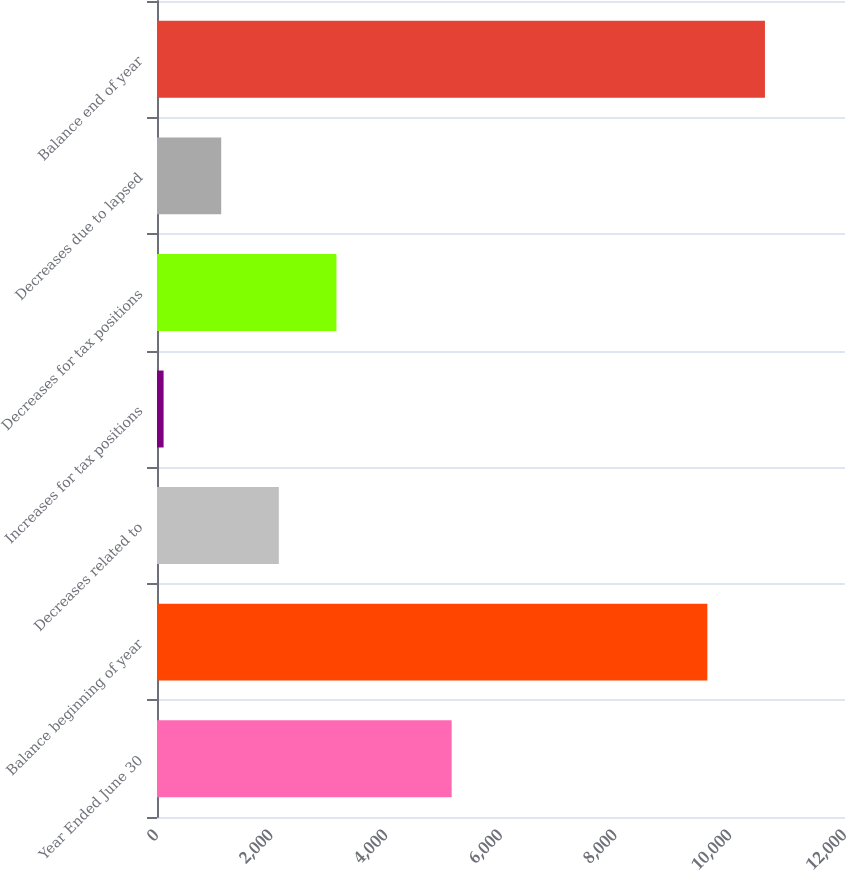<chart> <loc_0><loc_0><loc_500><loc_500><bar_chart><fcel>Year Ended June 30<fcel>Balance beginning of year<fcel>Decreases related to<fcel>Increases for tax positions<fcel>Decreases for tax positions<fcel>Decreases due to lapsed<fcel>Balance end of year<nl><fcel>5139.5<fcel>9599<fcel>2124.8<fcel>115<fcel>3129.7<fcel>1119.9<fcel>10603.9<nl></chart> 